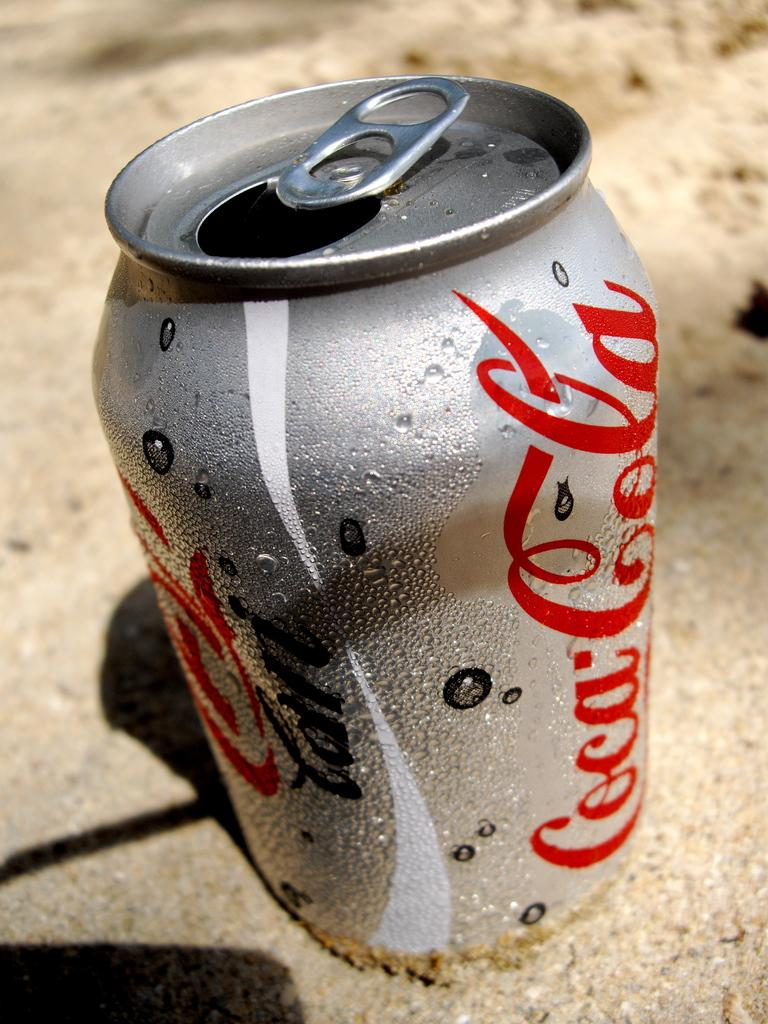<image>
Present a compact description of the photo's key features. A silver can of Coca Cola sits upon an outside surface 